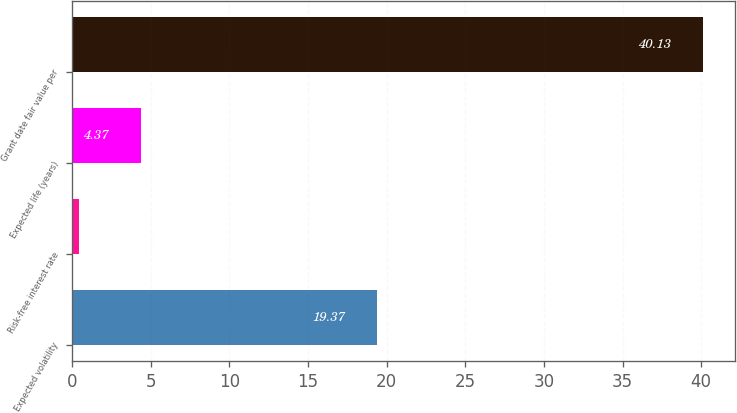Convert chart. <chart><loc_0><loc_0><loc_500><loc_500><bar_chart><fcel>Expected volatility<fcel>Risk-free interest rate<fcel>Expected life (years)<fcel>Grant date fair value per<nl><fcel>19.37<fcel>0.4<fcel>4.37<fcel>40.13<nl></chart> 